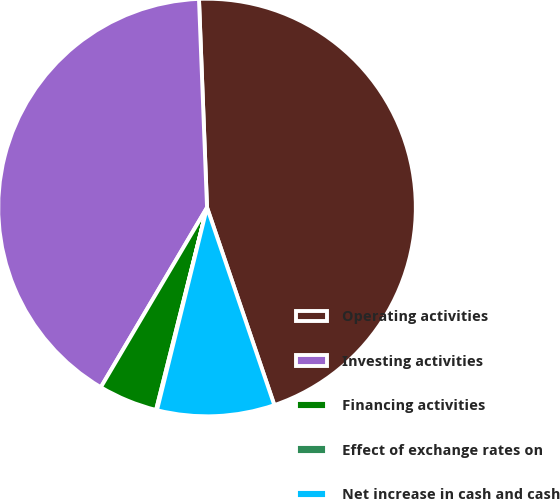<chart> <loc_0><loc_0><loc_500><loc_500><pie_chart><fcel>Operating activities<fcel>Investing activities<fcel>Financing activities<fcel>Effect of exchange rates on<fcel>Net increase in cash and cash<nl><fcel>45.39%<fcel>40.89%<fcel>4.57%<fcel>0.07%<fcel>9.08%<nl></chart> 